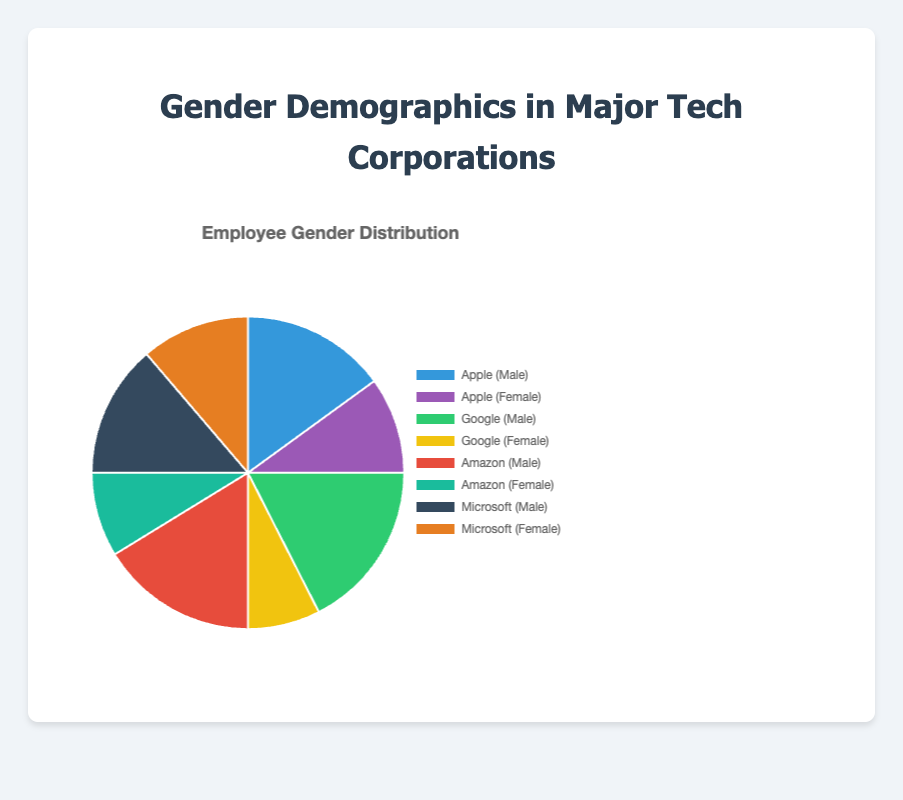Which company has the highest percentage of male employees? By observing the pie chart, we can visually compare the male employee segments for each company. Google has the largest segment for male employees.
Answer: Google Which company has the lowest percentage of female employees? By inspecting the chart for the smallest segment related to female employees, Google has the lowest percentage of female employees.
Answer: Google What is the combined percentage of male employees at Apple and Microsoft? Adding the percentage of male employees at Apple (60%) and Microsoft (55%) gives us 60% + 55% = 115%.
Answer: 115% What is the average percentage of female employees across all four companies? Summing the female percentages for Apple (40%), Google (30%), Amazon (35%), and Microsoft (45%) gives 40% + 30% + 35% + 45% = 150%. Dividing by 4 results in an average of 150% / 4 = 37.5%.
Answer: 37.5% What is the difference in the percentage of male employees between Amazon and Microsoft? Subtracting the male percentage of Microsoft (55%) from Amazon (65%) results in 65% - 55% = 10%.
Answer: 10% Which company has the most balanced gender distribution? By visually comparing the segments, Microsoft, with 55% male and 45% female employees, has the most balanced gender distribution.
Answer: Microsoft Which company's female employee percentage is closest to 40%? By looking at the chart, Apple's percentage of female employees (40%) is closest to the 40% mark.
Answer: Apple What is the total percentage of female employees in Google and Amazon combined? Adding the percentage of female employees in Google (30%) and Amazon (35%) gives us 30% + 35% = 65%.
Answer: 65% Compare the gender distribution of Apple and Google. Which company has a higher female percentage? By comparing the female segments, Apple has 40%, whereas Google has 30%. Thus, Apple has a higher female percentage.
Answer: Apple Based on the visual attributes, which color represents Amazon's female percentage in the chart? The color representing Amazon's female employees can be identified from the chart as green.
Answer: Green 